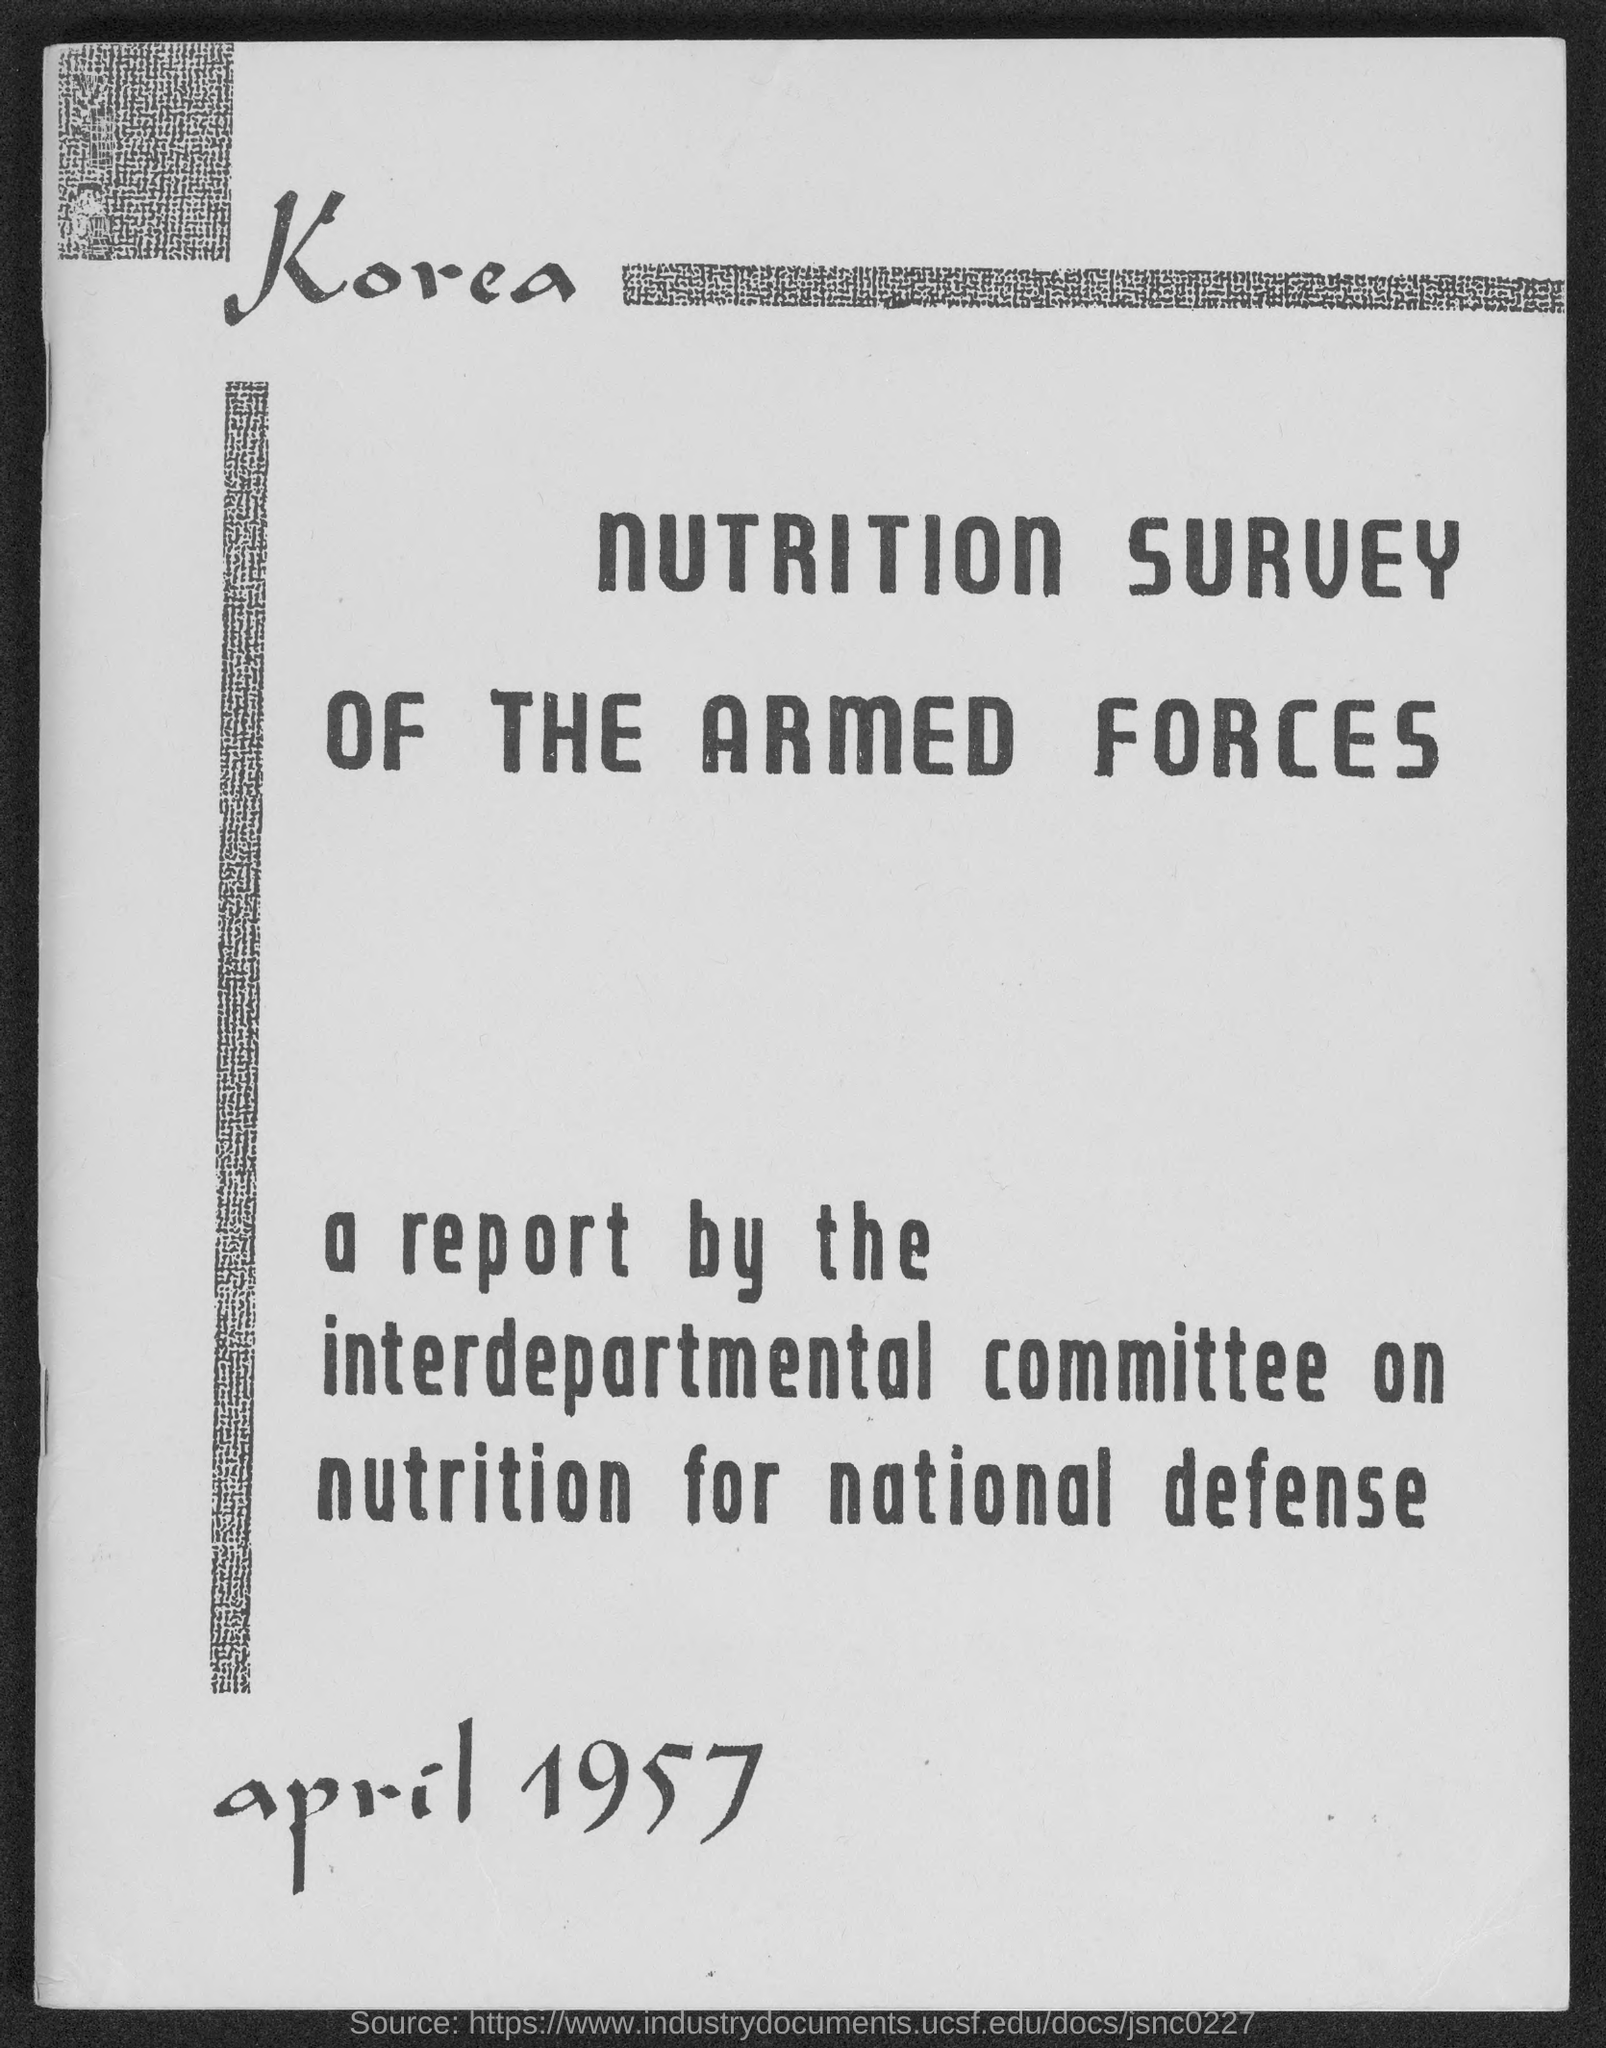What is the month and year at bottom of the  page ?
Make the answer very short. APRIL 1957. 